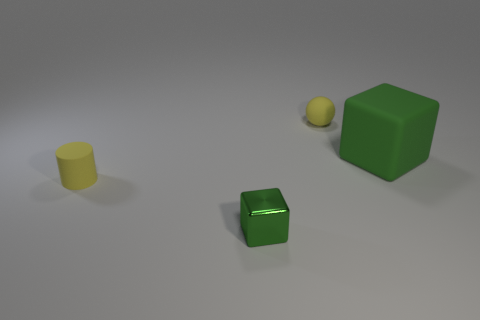Subtract 1 cubes. How many cubes are left? 1 Add 4 red things. How many objects exist? 8 Subtract all spheres. How many objects are left? 3 Subtract all rubber spheres. Subtract all small matte spheres. How many objects are left? 2 Add 1 big green cubes. How many big green cubes are left? 2 Add 1 yellow rubber objects. How many yellow rubber objects exist? 3 Subtract 0 brown balls. How many objects are left? 4 